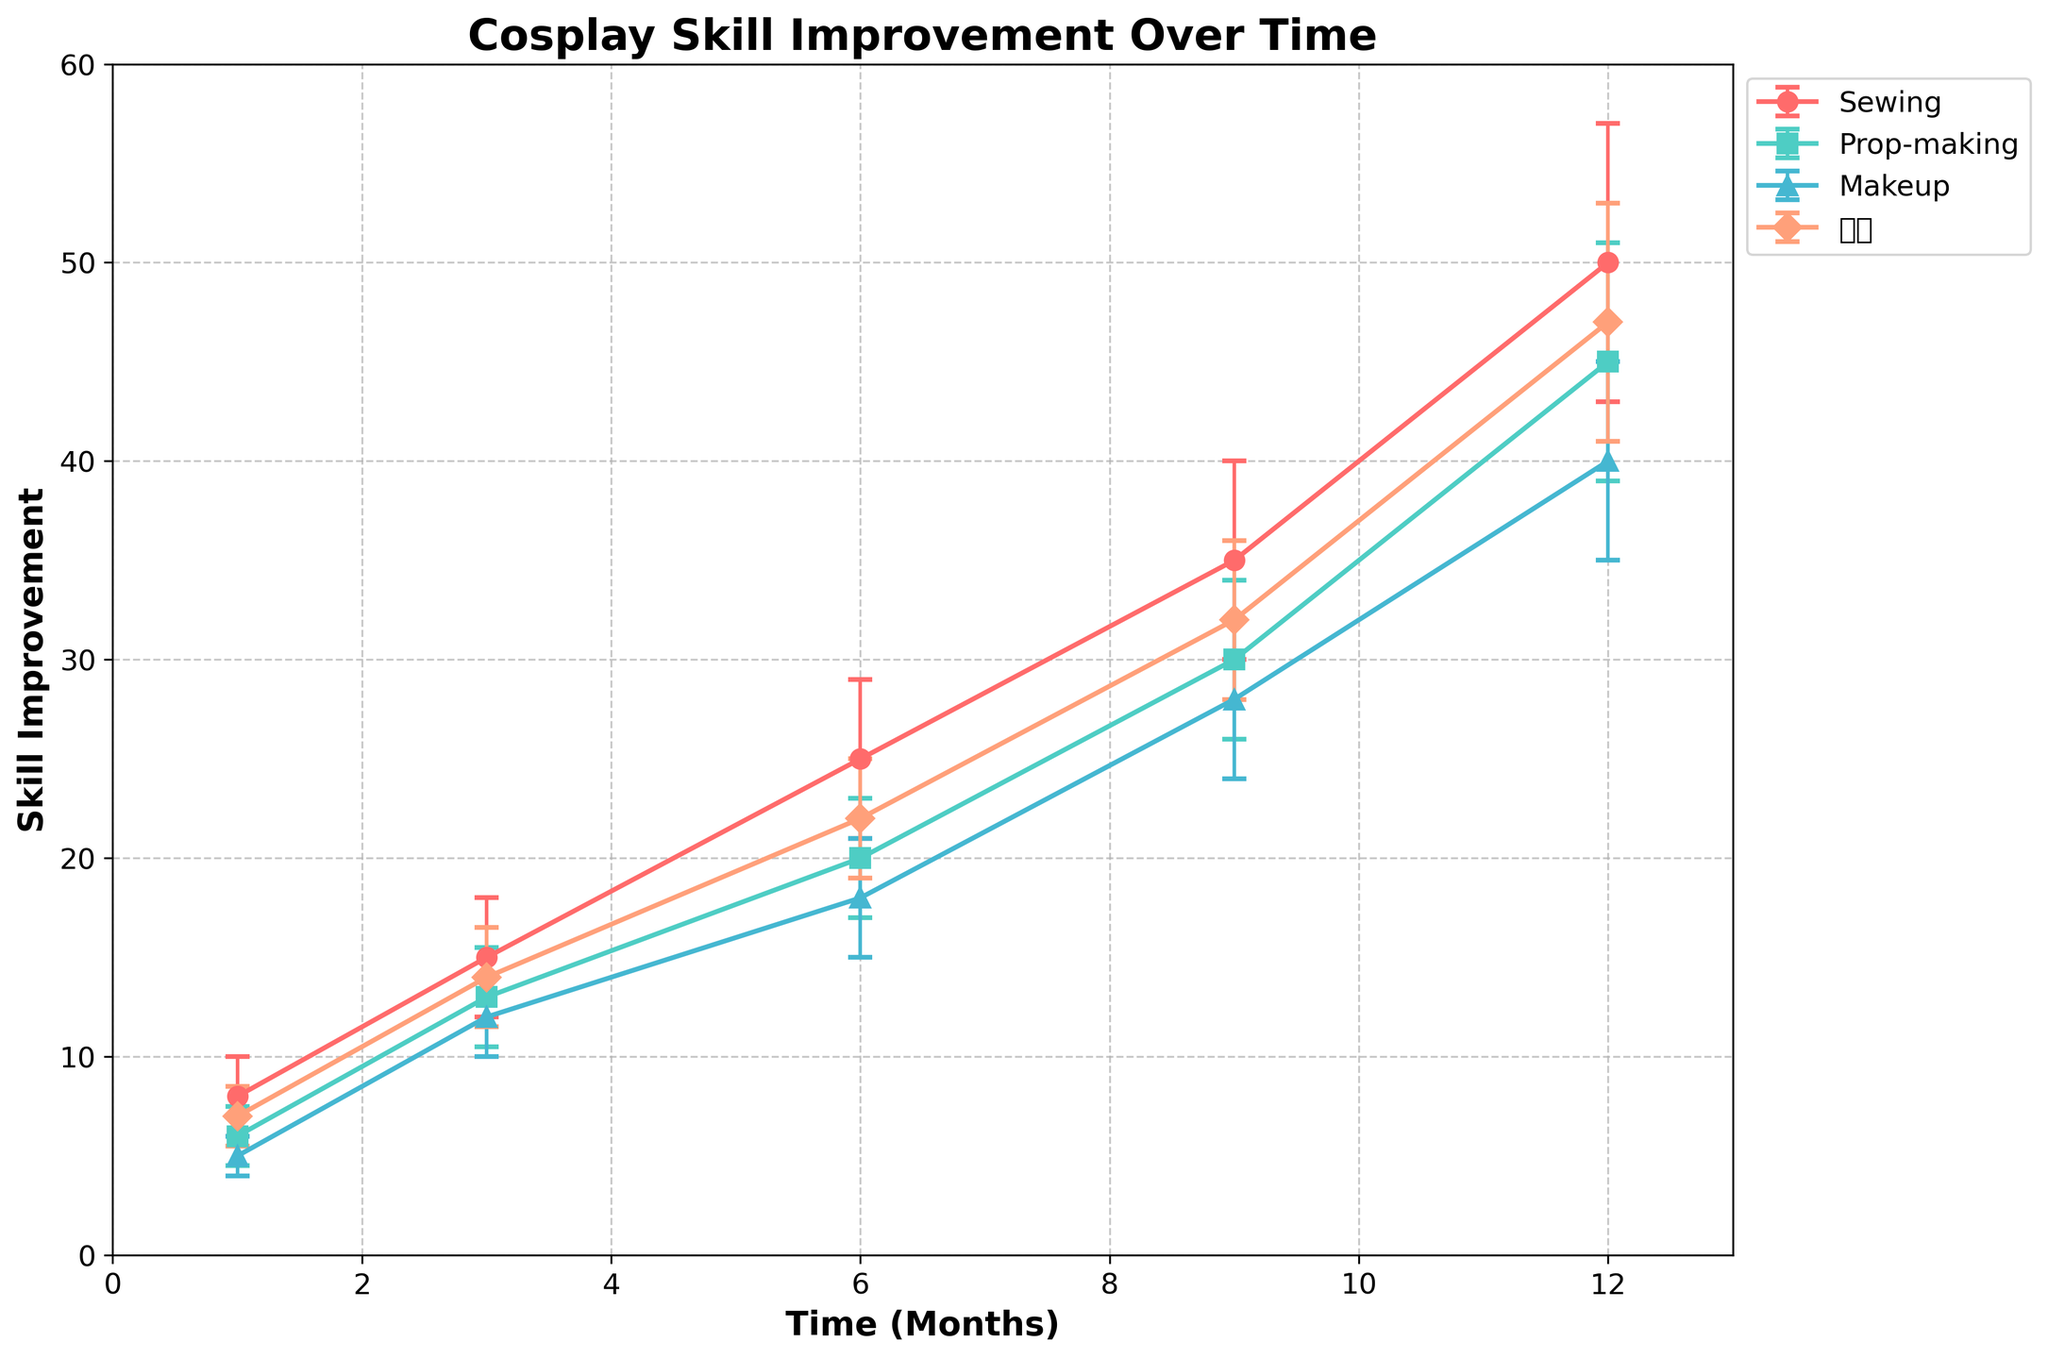What is the title of the figure? The title of the figure is generally found at the top center and is meant to provide a brief overview of what the plot represents. In this case, the title describes the overall focus of the plot.
Answer: Cosplay Skill Improvement Over Time What are the axis labels in the figure? The axis labels are positioned along the horizontal (x-axis) and vertical (y-axis) axes. They describe what each axis represents. Here, the x-axis label details time, and the y-axis label specifies the improvement metric.
Answer: Time (Months) and Skill Improvement How many total disciplines are displayed in the figure? The plot legend provides information on how many groups of data are represented in the figure. Each unique color and marker in the legend correspond to a different discipline.
Answer: Four disciplines Between which months does sewing show the greatest improvement? To determine the period of greatest improvement, compare the increase in mean improvement for each interval. For sewing: (1 to 3) +7, (3 to 6) +10, (6 to 9) +10, (9 to 12) +15.
Answer: Between 9 and 12 months Which cosplay discipline has the highest skill improvement after 6 months? Identify the data points for each discipline at the 6-month mark and compare the mean improvement values. Sewing: 25, Prop-making: 20, Makeup: 18, 绘画: 22.
Answer: Sewing What is the average standard deviation of prop-making over the time period? Sum the standard deviations for prop-making at each time point and divide by the number of time points. (1.5 + 2.5 + 3 + 4 + 6) / 5 = 17/5 = 3.4
Answer: 3.4 Which discipline shows the most consistent improvement (lowest standard deviation) at 12 months? Observe the standard deviation values at the 12-month mark for each discipline. Sewing: 7, Prop-making: 6, Makeup: 5, 绘画: 6. The lowest value indicates the most consistent improvement.
Answer: Makeup Is there any discipline that shows improvement less than 10 at any time point? Check all the data points for each discipline to see if there's any mean improvement value less than 10. Prop-making at 1 and 3 months: 6 and 13. Makeup at 1 month: 5. 绘画 at 1 month: 7.
Answer: Yes Which discipline's skill improvement shows the steepest increase during the 9 to 12-month period? Find the difference in mean improvement between 9 and 12 months for each discipline and compare. Sewing: 15, Prop-making: 15, Makeup: 12, 绘画: 15. Multiple disciplines with the same value can be identified.
Answer: Sewing, Prop-making, and 绘画 